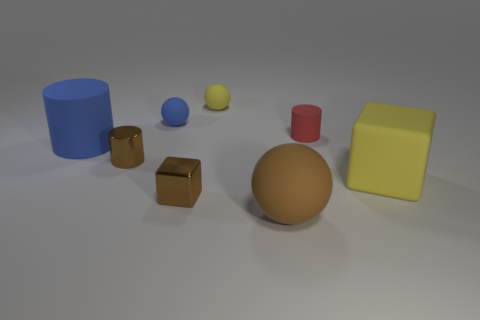What is the material of the big brown object that is the same shape as the small blue thing?
Offer a very short reply. Rubber. There is a tiny cylinder that is behind the blue matte thing that is in front of the tiny red matte cylinder; how many big things are to the left of it?
Make the answer very short. 2. Is there anything else that is the same color as the large rubber block?
Provide a succinct answer. Yes. How many small objects are both behind the large yellow matte thing and left of the small red cylinder?
Your answer should be very brief. 3. Does the yellow rubber cube that is behind the large matte ball have the same size as the rubber cylinder that is behind the large blue matte cylinder?
Ensure brevity in your answer.  No. How many things are yellow things that are right of the red matte cylinder or yellow rubber balls?
Offer a terse response. 2. There is a blue thing that is left of the tiny brown metal cylinder; what is it made of?
Your answer should be compact. Rubber. What is the brown sphere made of?
Make the answer very short. Rubber. What is the material of the thing in front of the shiny thing in front of the tiny cylinder that is in front of the small red matte cylinder?
Provide a short and direct response. Rubber. Is there any other thing that has the same material as the small yellow ball?
Your response must be concise. Yes. 